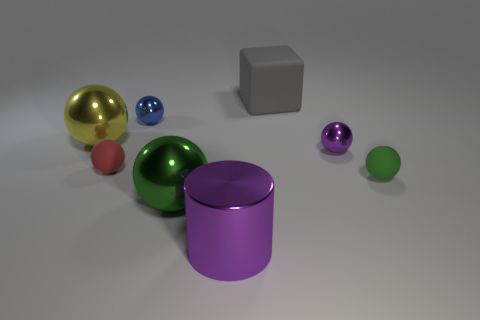How many other things are there of the same shape as the large green object?
Provide a short and direct response. 5. What number of metal things are purple objects or large blue objects?
Your answer should be very brief. 2. What material is the small red object that is on the left side of the tiny shiny thing that is to the right of the tiny blue metal sphere?
Your answer should be very brief. Rubber. Are there more gray blocks left of the yellow metallic sphere than cylinders?
Your answer should be very brief. No. Are there any other big cubes made of the same material as the big cube?
Offer a very short reply. No. There is a small matte thing to the right of the big purple metallic object; is its shape the same as the red object?
Offer a terse response. Yes. How many green balls are in front of the small matte object that is in front of the rubber thing that is to the left of the large cube?
Offer a terse response. 1. Are there fewer tiny matte balls that are left of the large gray rubber thing than tiny objects on the right side of the green matte ball?
Keep it short and to the point. No. There is another large thing that is the same shape as the yellow metal thing; what is its color?
Offer a very short reply. Green. The red rubber sphere has what size?
Ensure brevity in your answer.  Small. 